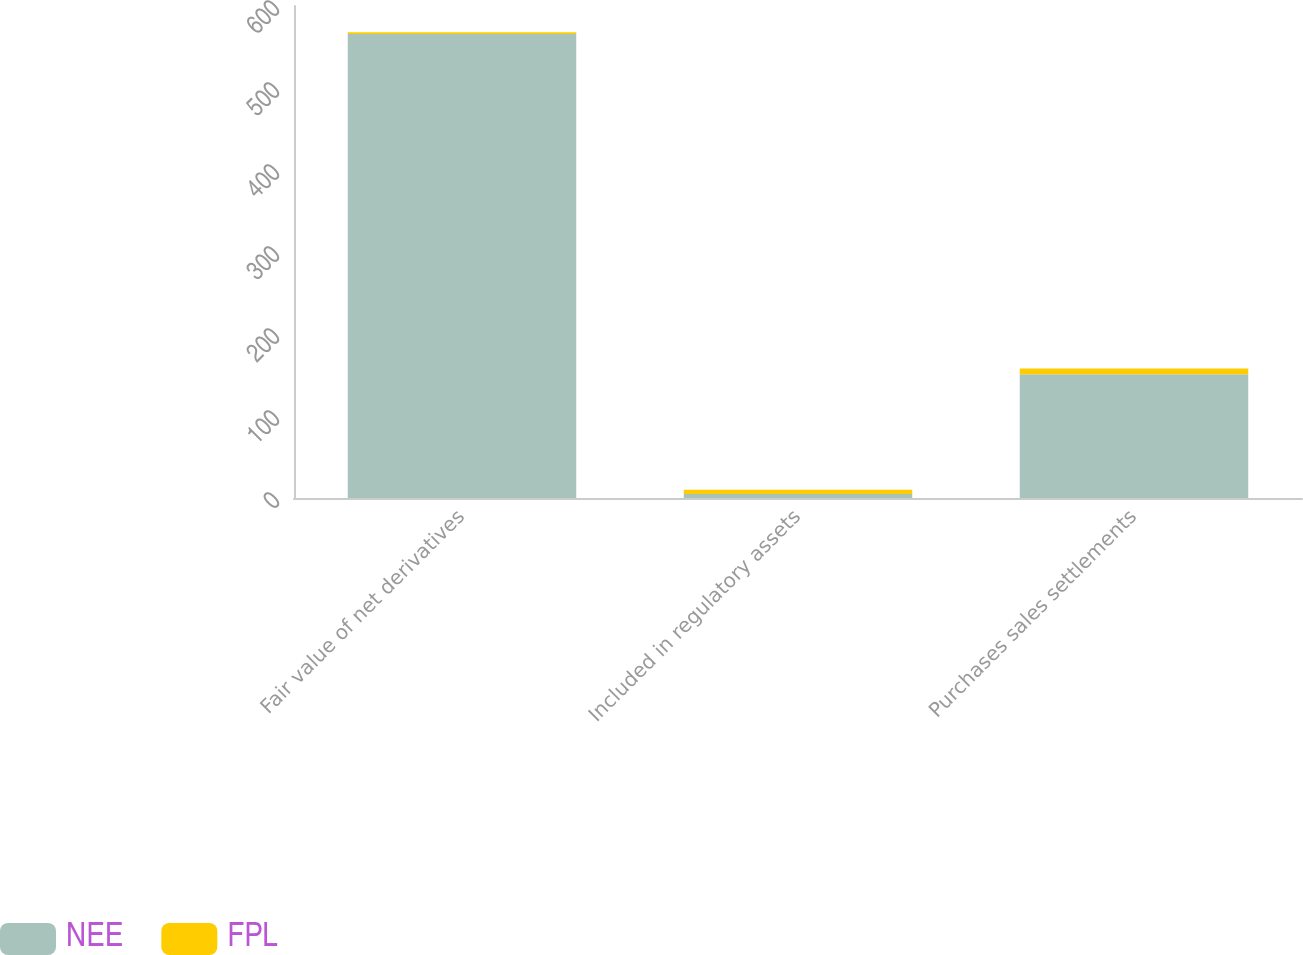Convert chart to OTSL. <chart><loc_0><loc_0><loc_500><loc_500><stacked_bar_chart><ecel><fcel>Fair value of net derivatives<fcel>Included in regulatory assets<fcel>Purchases sales settlements<nl><fcel>NEE<fcel>566<fcel>5<fcel>151<nl><fcel>FPL<fcel>2<fcel>5<fcel>7<nl></chart> 